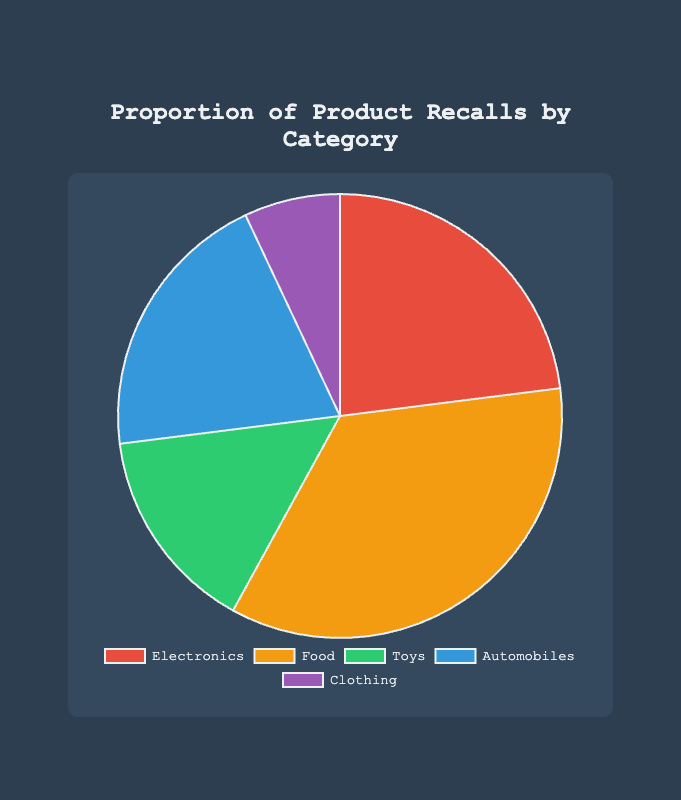Which category has the highest proportion of product recalls? The category with the highest percentage in the pie chart represents the category with the highest proportion of product recalls. From the provided percentages, Food (35%) is the highest.
Answer: Food What is the combined percentage of Electronics and Automobiles recalls? To find the combined percentage, add the percentages for Electronics and Automobiles. Electronics is 23% and Automobiles is 20%, so 23% + 20% = 43%.
Answer: 43% Which category has a smaller proportion of recalls, Toys or Clothing? Comparing the percentages, Toys have 15% and Clothing has 7%. Since 7% is smaller than 15%, Clothing has a smaller proportion of recalls.
Answer: Clothing What is the difference in recall proportions between the category with the highest proportion and the category with the lowest proportion? The highest proportion is Food at 35%, and the lowest proportion is Clothing at 7%. The difference is 35% - 7% = 28%.
Answer: 28% What is the average recall proportion for all categories? Add the percentages of all categories and then divide by the number of categories. The sum is 23% + 35% + 15% + 20% + 7% = 100%. The number of categories is 5. So, 100% / 5 = 20%.
Answer: 20% If the recalls of Toys and Clothing were combined into a single category, what would be the percentage of recalls for this new category? Add the percentages of Toys and Clothing to find the combined recalls. Toys have 15% and Clothing has 7%, so 15% + 7% = 22%.
Answer: 22% Which two categories have the closest recall proportions? To find the closest recall proportions, compare the differences between each pair of proportions: 
Electronics (23%) and Automobiles (20%) difference is 3%,
Food (35%) and Electronics (23%) difference is 12%,
Toys (15%) and Clothing (7%) difference is 8%, etc.
The closest difference is between Electronics and Automobiles at 3%.
Answer: Electronics and Automobiles What is the proportion of recalls in categories that have a proportion greater than 20%? Identify the categories with more than 20%: Electronics (23%) and Food (35%). Sum these percentages: 23% + 35% = 58%.
Answer: 58% 